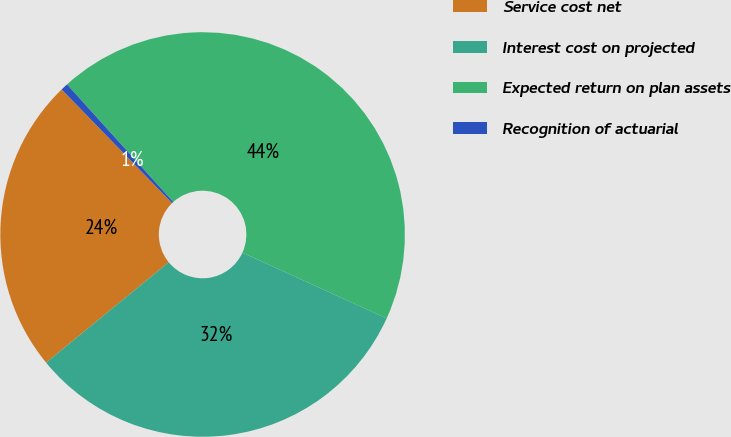<chart> <loc_0><loc_0><loc_500><loc_500><pie_chart><fcel>Service cost net<fcel>Interest cost on projected<fcel>Expected return on plan assets<fcel>Recognition of actuarial<nl><fcel>23.65%<fcel>32.27%<fcel>43.5%<fcel>0.58%<nl></chart> 